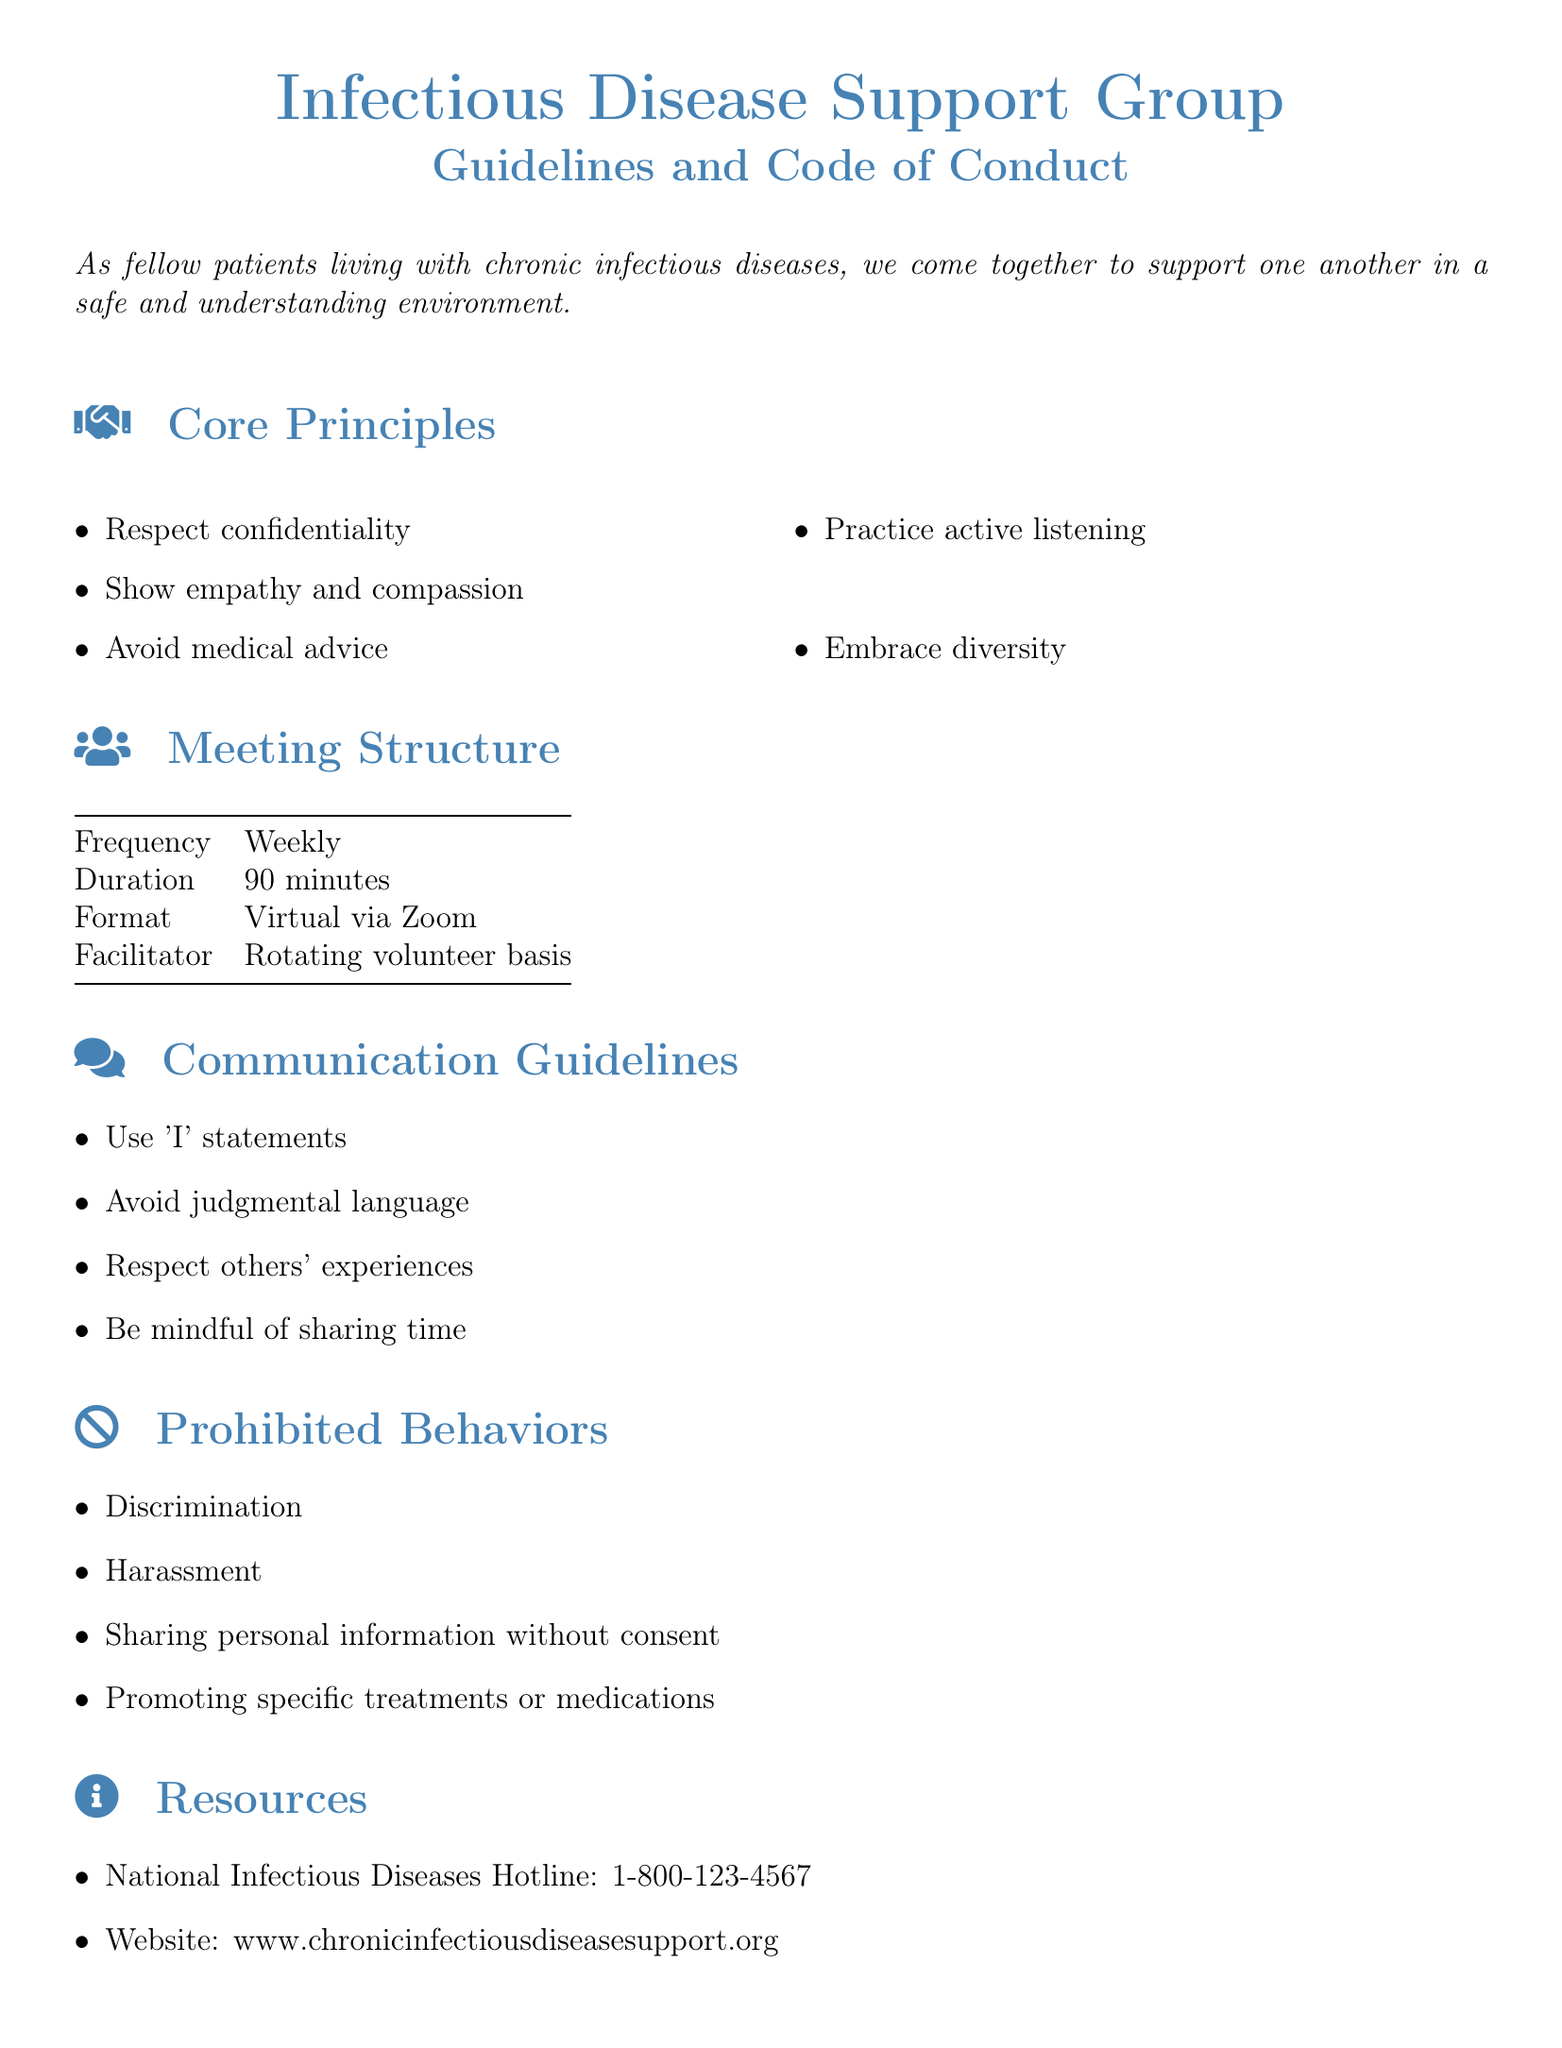what is the meeting frequency? The document states that meetings occur on a weekly basis.
Answer: Weekly what is the duration of each meeting? The document specifies the duration of each meeting as 90 minutes.
Answer: 90 minutes what platform is used for meetings? According to the document, the meetings are held virtually via Zoom.
Answer: Zoom who facilitates the meetings? The document mentions that the facilitator is on a rotating volunteer basis.
Answer: Rotating volunteer basis list one core principle of the support group. The document highlights several core principles, including respect for confidentiality.
Answer: Respect confidentiality what is one of the prohibited behaviors? The document specifies discrimination as one of the prohibited behaviors.
Answer: Discrimination how should group members address concerns? Group members are instructed to address concerns privately with the group facilitator.
Answer: Privately with the group facilitator what hotline number is provided in the resources? The document lists the National Infectious Diseases Hotline as 1-800-123-4567.
Answer: 1-800-123-4567 what is the agreement signature space for? The signature space in the document is for participants to agree to adhere to the guidelines.
Answer: Adhere to the guidelines 